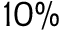<formula> <loc_0><loc_0><loc_500><loc_500>1 0 \%</formula> 